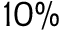<formula> <loc_0><loc_0><loc_500><loc_500>1 0 \%</formula> 